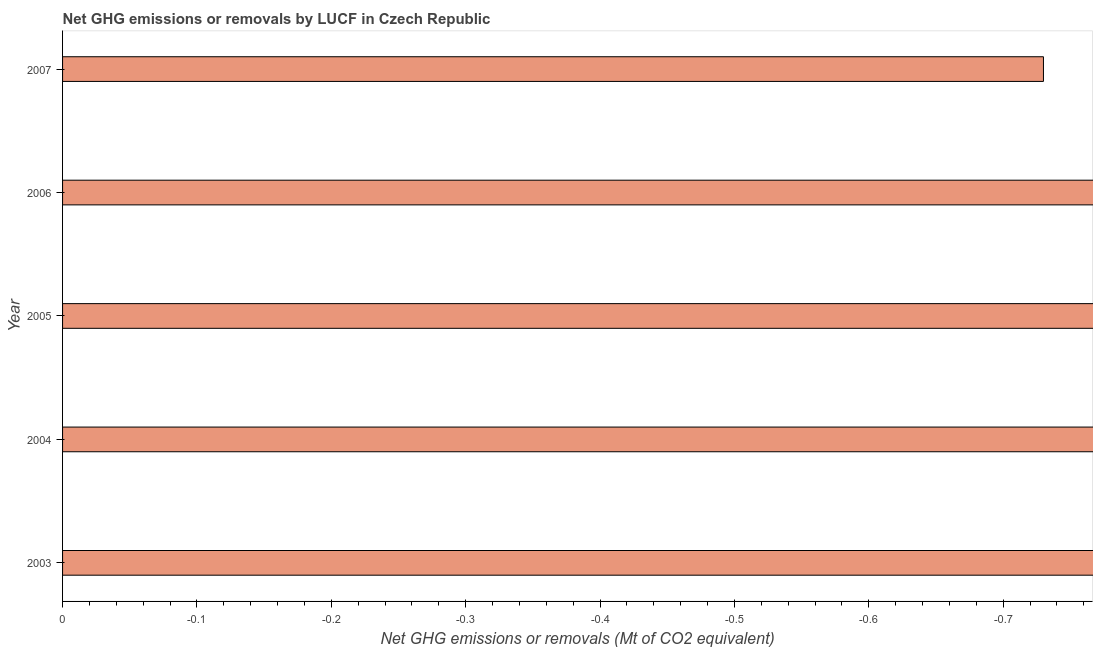Does the graph contain any zero values?
Offer a terse response. Yes. What is the title of the graph?
Keep it short and to the point. Net GHG emissions or removals by LUCF in Czech Republic. What is the label or title of the X-axis?
Offer a very short reply. Net GHG emissions or removals (Mt of CO2 equivalent). What is the label or title of the Y-axis?
Give a very brief answer. Year. What is the sum of the ghg net emissions or removals?
Offer a very short reply. 0. What is the average ghg net emissions or removals per year?
Your answer should be compact. 0. How many bars are there?
Your response must be concise. 0. Are all the bars in the graph horizontal?
Provide a short and direct response. Yes. How many years are there in the graph?
Your answer should be compact. 5. What is the difference between two consecutive major ticks on the X-axis?
Ensure brevity in your answer.  0.1. Are the values on the major ticks of X-axis written in scientific E-notation?
Give a very brief answer. No. What is the Net GHG emissions or removals (Mt of CO2 equivalent) of 2003?
Make the answer very short. 0. 